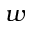Convert formula to latex. <formula><loc_0><loc_0><loc_500><loc_500>w</formula> 